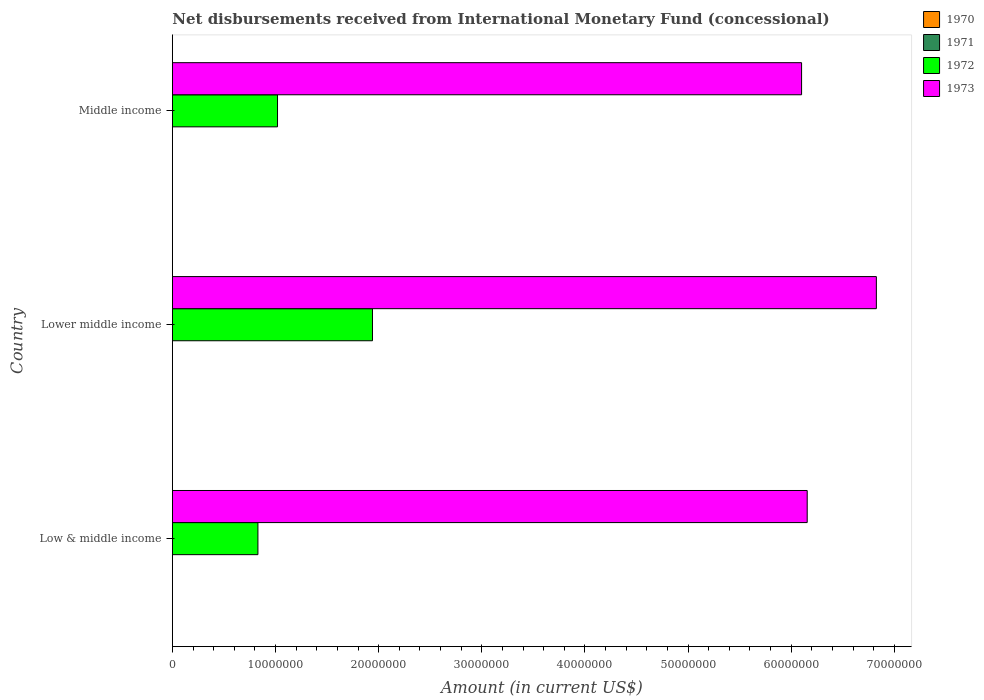How many different coloured bars are there?
Make the answer very short. 2. How many groups of bars are there?
Your answer should be compact. 3. Are the number of bars per tick equal to the number of legend labels?
Offer a very short reply. No. How many bars are there on the 1st tick from the bottom?
Your answer should be compact. 2. What is the label of the 3rd group of bars from the top?
Offer a very short reply. Low & middle income. Across all countries, what is the maximum amount of disbursements received from International Monetary Fund in 1973?
Ensure brevity in your answer.  6.83e+07. In which country was the amount of disbursements received from International Monetary Fund in 1973 maximum?
Ensure brevity in your answer.  Lower middle income. What is the total amount of disbursements received from International Monetary Fund in 1970 in the graph?
Your answer should be very brief. 0. What is the difference between the amount of disbursements received from International Monetary Fund in 1973 in Low & middle income and that in Lower middle income?
Give a very brief answer. -6.70e+06. What is the difference between the amount of disbursements received from International Monetary Fund in 1972 in Lower middle income and the amount of disbursements received from International Monetary Fund in 1970 in Middle income?
Provide a short and direct response. 1.94e+07. What is the average amount of disbursements received from International Monetary Fund in 1972 per country?
Give a very brief answer. 1.26e+07. What is the difference between the amount of disbursements received from International Monetary Fund in 1972 and amount of disbursements received from International Monetary Fund in 1973 in Middle income?
Give a very brief answer. -5.08e+07. What is the ratio of the amount of disbursements received from International Monetary Fund in 1972 in Low & middle income to that in Middle income?
Your answer should be compact. 0.81. Is the difference between the amount of disbursements received from International Monetary Fund in 1972 in Low & middle income and Lower middle income greater than the difference between the amount of disbursements received from International Monetary Fund in 1973 in Low & middle income and Lower middle income?
Provide a succinct answer. No. What is the difference between the highest and the second highest amount of disbursements received from International Monetary Fund in 1973?
Give a very brief answer. 6.70e+06. What is the difference between the highest and the lowest amount of disbursements received from International Monetary Fund in 1972?
Give a very brief answer. 1.11e+07. In how many countries, is the amount of disbursements received from International Monetary Fund in 1972 greater than the average amount of disbursements received from International Monetary Fund in 1972 taken over all countries?
Keep it short and to the point. 1. Is it the case that in every country, the sum of the amount of disbursements received from International Monetary Fund in 1972 and amount of disbursements received from International Monetary Fund in 1973 is greater than the amount of disbursements received from International Monetary Fund in 1970?
Make the answer very short. Yes. What is the difference between two consecutive major ticks on the X-axis?
Provide a succinct answer. 1.00e+07. Are the values on the major ticks of X-axis written in scientific E-notation?
Offer a terse response. No. Does the graph contain any zero values?
Provide a short and direct response. Yes. Does the graph contain grids?
Ensure brevity in your answer.  No. Where does the legend appear in the graph?
Provide a short and direct response. Top right. How are the legend labels stacked?
Your answer should be compact. Vertical. What is the title of the graph?
Offer a very short reply. Net disbursements received from International Monetary Fund (concessional). Does "1977" appear as one of the legend labels in the graph?
Provide a succinct answer. No. What is the label or title of the X-axis?
Your answer should be compact. Amount (in current US$). What is the Amount (in current US$) of 1970 in Low & middle income?
Offer a very short reply. 0. What is the Amount (in current US$) of 1972 in Low & middle income?
Your response must be concise. 8.30e+06. What is the Amount (in current US$) in 1973 in Low & middle income?
Keep it short and to the point. 6.16e+07. What is the Amount (in current US$) of 1970 in Lower middle income?
Keep it short and to the point. 0. What is the Amount (in current US$) of 1972 in Lower middle income?
Offer a very short reply. 1.94e+07. What is the Amount (in current US$) of 1973 in Lower middle income?
Ensure brevity in your answer.  6.83e+07. What is the Amount (in current US$) of 1970 in Middle income?
Offer a very short reply. 0. What is the Amount (in current US$) of 1971 in Middle income?
Your response must be concise. 0. What is the Amount (in current US$) in 1972 in Middle income?
Make the answer very short. 1.02e+07. What is the Amount (in current US$) in 1973 in Middle income?
Keep it short and to the point. 6.10e+07. Across all countries, what is the maximum Amount (in current US$) of 1972?
Your response must be concise. 1.94e+07. Across all countries, what is the maximum Amount (in current US$) in 1973?
Offer a very short reply. 6.83e+07. Across all countries, what is the minimum Amount (in current US$) of 1972?
Provide a succinct answer. 8.30e+06. Across all countries, what is the minimum Amount (in current US$) in 1973?
Provide a succinct answer. 6.10e+07. What is the total Amount (in current US$) of 1970 in the graph?
Your response must be concise. 0. What is the total Amount (in current US$) of 1972 in the graph?
Your answer should be very brief. 3.79e+07. What is the total Amount (in current US$) in 1973 in the graph?
Give a very brief answer. 1.91e+08. What is the difference between the Amount (in current US$) of 1972 in Low & middle income and that in Lower middle income?
Provide a short and direct response. -1.11e+07. What is the difference between the Amount (in current US$) of 1973 in Low & middle income and that in Lower middle income?
Provide a succinct answer. -6.70e+06. What is the difference between the Amount (in current US$) of 1972 in Low & middle income and that in Middle income?
Provide a succinct answer. -1.90e+06. What is the difference between the Amount (in current US$) of 1973 in Low & middle income and that in Middle income?
Offer a very short reply. 5.46e+05. What is the difference between the Amount (in current US$) of 1972 in Lower middle income and that in Middle income?
Provide a succinct answer. 9.21e+06. What is the difference between the Amount (in current US$) in 1973 in Lower middle income and that in Middle income?
Your answer should be very brief. 7.25e+06. What is the difference between the Amount (in current US$) of 1972 in Low & middle income and the Amount (in current US$) of 1973 in Lower middle income?
Offer a very short reply. -6.00e+07. What is the difference between the Amount (in current US$) in 1972 in Low & middle income and the Amount (in current US$) in 1973 in Middle income?
Make the answer very short. -5.27e+07. What is the difference between the Amount (in current US$) of 1972 in Lower middle income and the Amount (in current US$) of 1973 in Middle income?
Your response must be concise. -4.16e+07. What is the average Amount (in current US$) in 1972 per country?
Provide a succinct answer. 1.26e+07. What is the average Amount (in current US$) in 1973 per country?
Provide a short and direct response. 6.36e+07. What is the difference between the Amount (in current US$) of 1972 and Amount (in current US$) of 1973 in Low & middle income?
Offer a terse response. -5.33e+07. What is the difference between the Amount (in current US$) of 1972 and Amount (in current US$) of 1973 in Lower middle income?
Ensure brevity in your answer.  -4.89e+07. What is the difference between the Amount (in current US$) of 1972 and Amount (in current US$) of 1973 in Middle income?
Ensure brevity in your answer.  -5.08e+07. What is the ratio of the Amount (in current US$) of 1972 in Low & middle income to that in Lower middle income?
Your answer should be compact. 0.43. What is the ratio of the Amount (in current US$) in 1973 in Low & middle income to that in Lower middle income?
Your answer should be compact. 0.9. What is the ratio of the Amount (in current US$) of 1972 in Low & middle income to that in Middle income?
Offer a very short reply. 0.81. What is the ratio of the Amount (in current US$) in 1972 in Lower middle income to that in Middle income?
Keep it short and to the point. 1.9. What is the ratio of the Amount (in current US$) of 1973 in Lower middle income to that in Middle income?
Ensure brevity in your answer.  1.12. What is the difference between the highest and the second highest Amount (in current US$) in 1972?
Your response must be concise. 9.21e+06. What is the difference between the highest and the second highest Amount (in current US$) in 1973?
Provide a short and direct response. 6.70e+06. What is the difference between the highest and the lowest Amount (in current US$) of 1972?
Offer a very short reply. 1.11e+07. What is the difference between the highest and the lowest Amount (in current US$) in 1973?
Provide a succinct answer. 7.25e+06. 